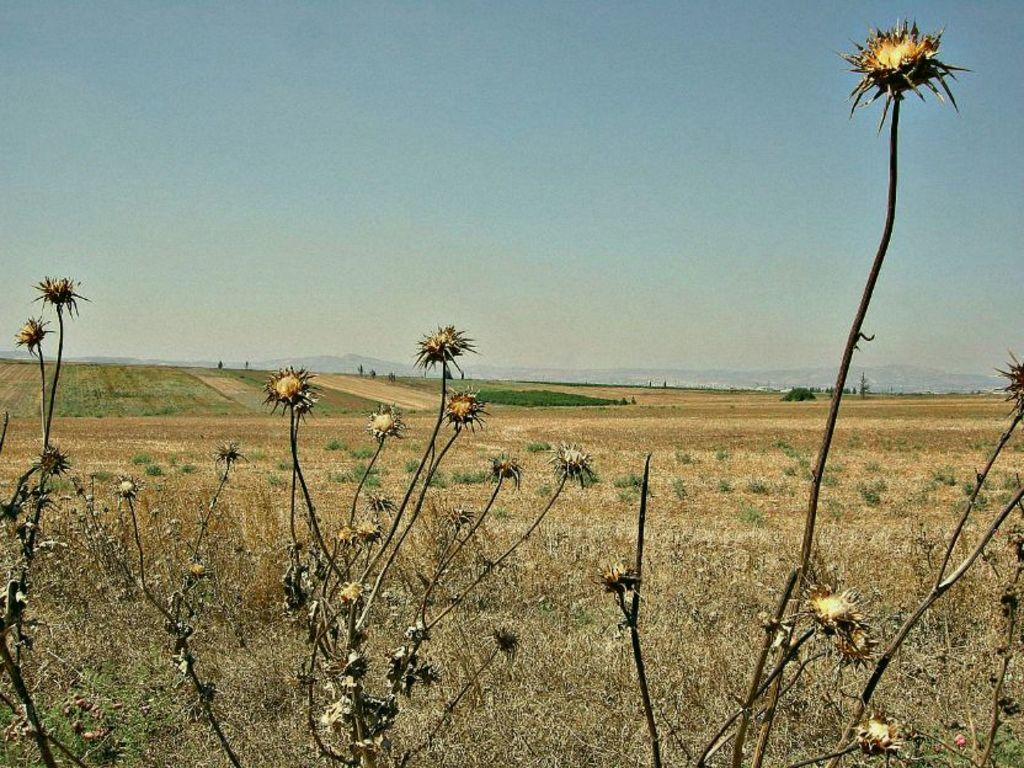What objects are on the ground in the image? There are planets on the ground in the image. What type of vegetation is visible in the image? There is grass visible in the image. What can be seen in the background of the image? The sky is visible in the background of the image. How many toes can be seen on the foot of the beginner in the image? There is no foot or beginner present in the image; it features planets on the ground and grass. 